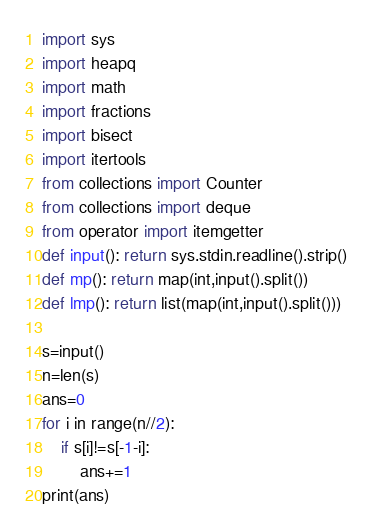Convert code to text. <code><loc_0><loc_0><loc_500><loc_500><_Python_>import sys
import heapq
import math
import fractions
import bisect
import itertools
from collections import Counter
from collections import deque
from operator import itemgetter
def input(): return sys.stdin.readline().strip()
def mp(): return map(int,input().split())
def lmp(): return list(map(int,input().split()))

s=input()
n=len(s)
ans=0
for i in range(n//2):
    if s[i]!=s[-1-i]:
        ans+=1
print(ans)</code> 